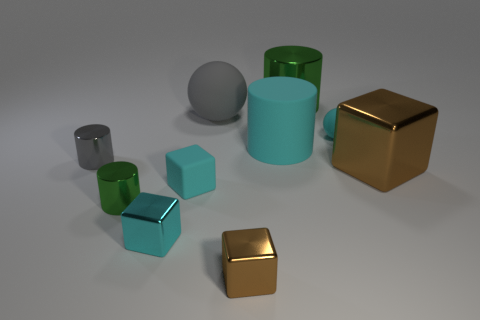How many cyan blocks must be subtracted to get 1 cyan blocks? 1 Subtract 1 blocks. How many blocks are left? 3 Subtract all cylinders. How many objects are left? 6 Subtract all blocks. Subtract all big green objects. How many objects are left? 5 Add 2 gray metallic things. How many gray metallic things are left? 3 Add 9 tiny green cylinders. How many tiny green cylinders exist? 10 Subtract 0 red balls. How many objects are left? 10 